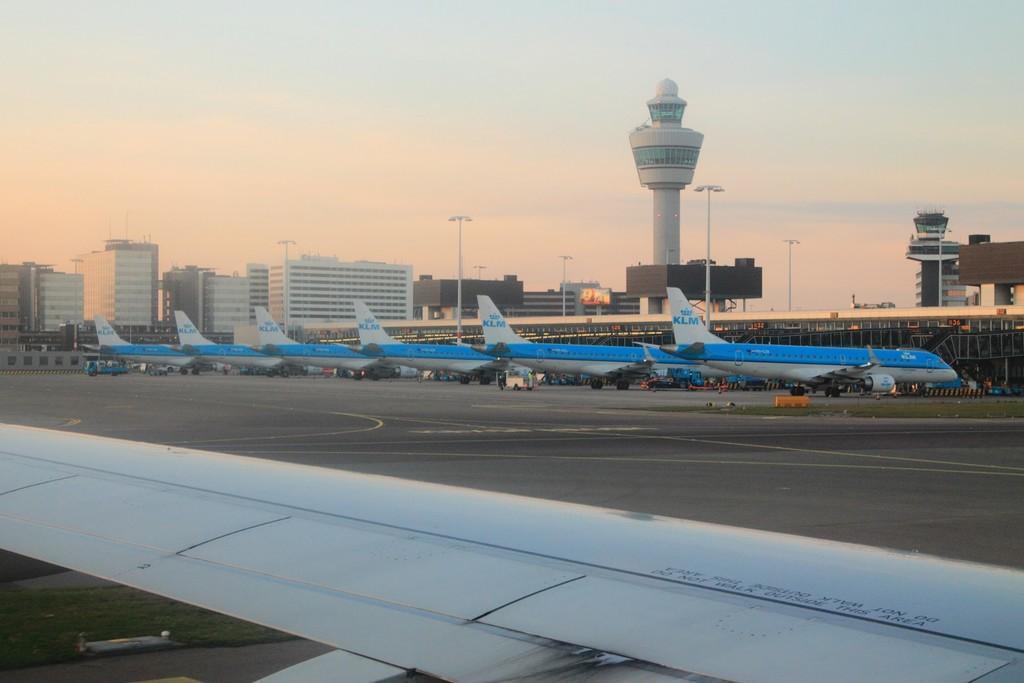In one or two sentences, can you explain what this image depicts? This is an airport and here we can see aeroplanes. In the background, there are buildings, poles and towers. At the bottom, there is road and at the top, there is sky. 